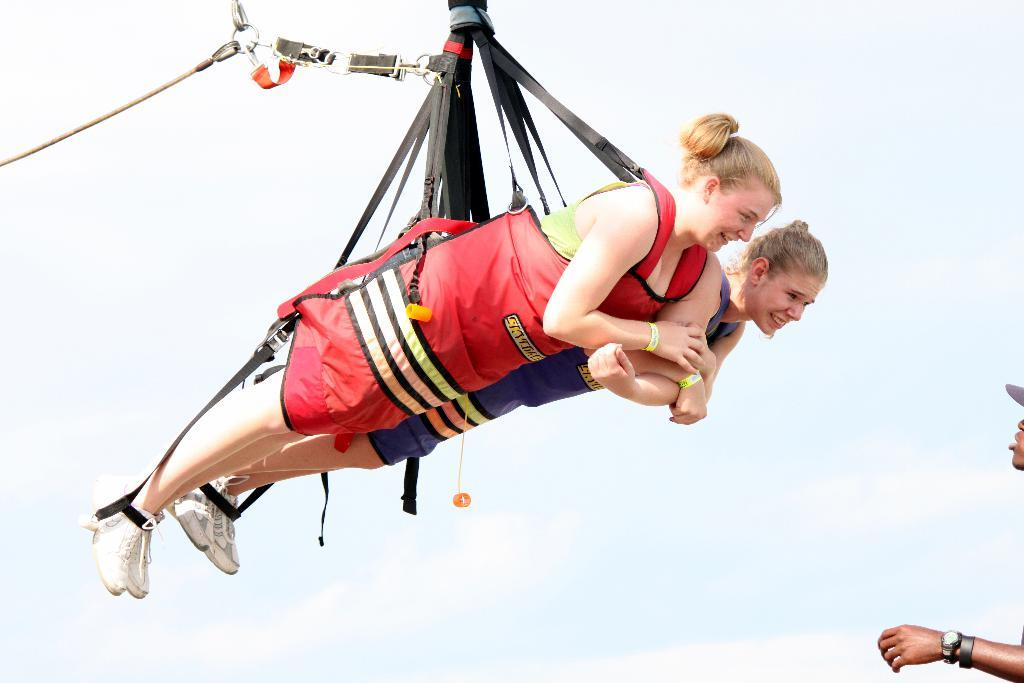What are the two women in the image doing? The two women are hanging from a rope in the image. How do the women appear in the image? Both women are smiling in the image. Can you describe the person on the right side of the image? There is another person on the right side of the image, but their actions or appearance are not specified in the facts. What can be seen in the background of the image? The sky is visible in the background of the image. What type of butter is being used by the women in the image? There is no butter present in the image; the women are hanging from a rope and smiling. 